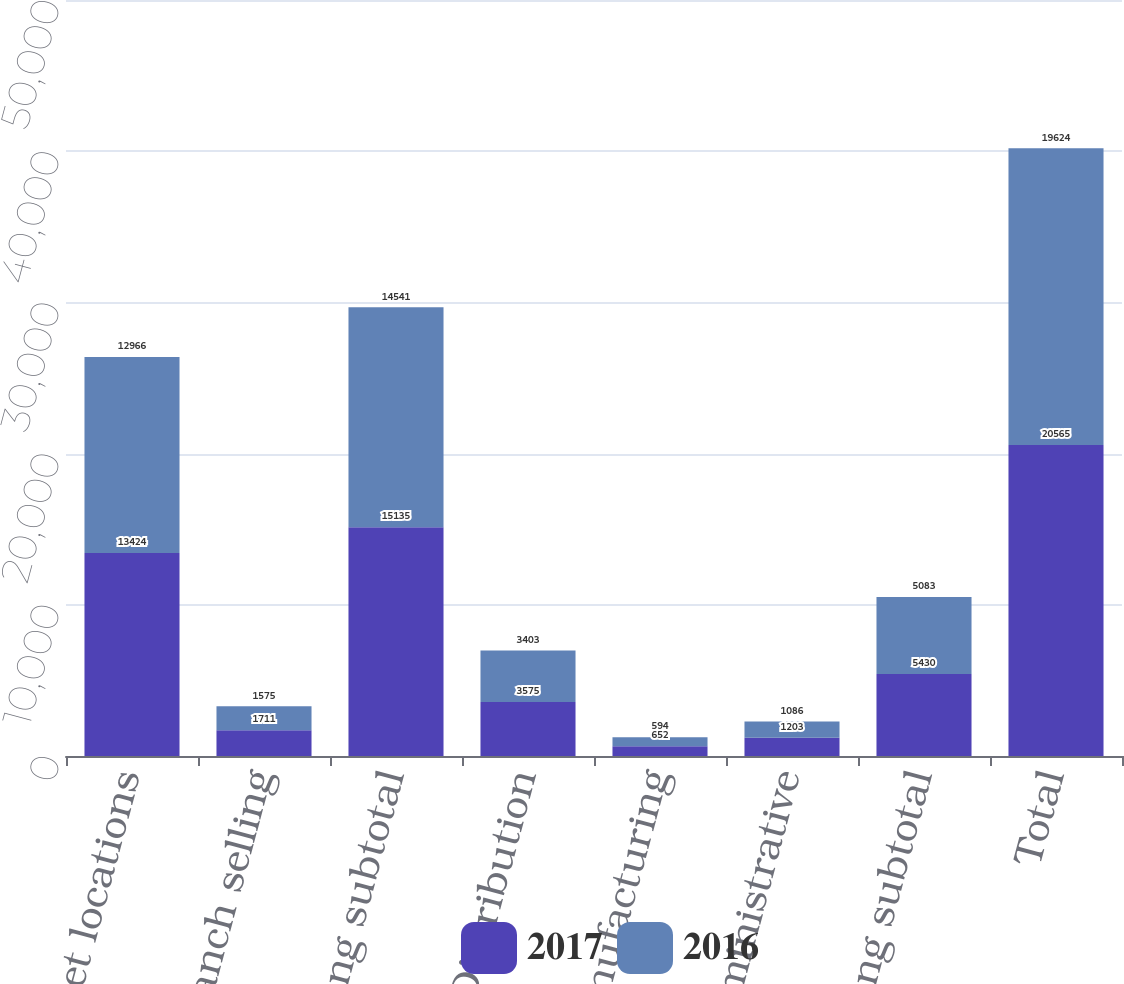<chart> <loc_0><loc_0><loc_500><loc_500><stacked_bar_chart><ecel><fcel>In-market locations<fcel>Non-branch selling<fcel>Selling subtotal<fcel>Distribution<fcel>Manufacturing<fcel>Administrative<fcel>Non-selling subtotal<fcel>Total<nl><fcel>2017<fcel>13424<fcel>1711<fcel>15135<fcel>3575<fcel>652<fcel>1203<fcel>5430<fcel>20565<nl><fcel>2016<fcel>12966<fcel>1575<fcel>14541<fcel>3403<fcel>594<fcel>1086<fcel>5083<fcel>19624<nl></chart> 